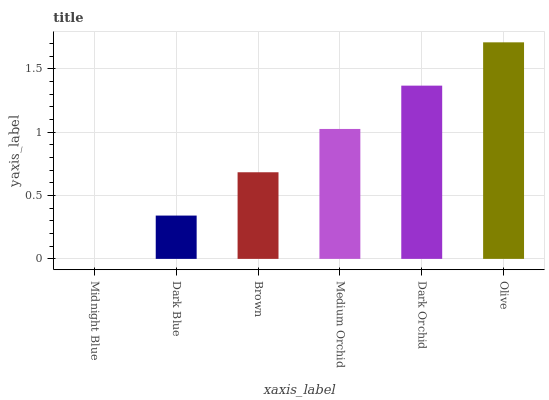Is Midnight Blue the minimum?
Answer yes or no. Yes. Is Olive the maximum?
Answer yes or no. Yes. Is Dark Blue the minimum?
Answer yes or no. No. Is Dark Blue the maximum?
Answer yes or no. No. Is Dark Blue greater than Midnight Blue?
Answer yes or no. Yes. Is Midnight Blue less than Dark Blue?
Answer yes or no. Yes. Is Midnight Blue greater than Dark Blue?
Answer yes or no. No. Is Dark Blue less than Midnight Blue?
Answer yes or no. No. Is Medium Orchid the high median?
Answer yes or no. Yes. Is Brown the low median?
Answer yes or no. Yes. Is Dark Blue the high median?
Answer yes or no. No. Is Midnight Blue the low median?
Answer yes or no. No. 